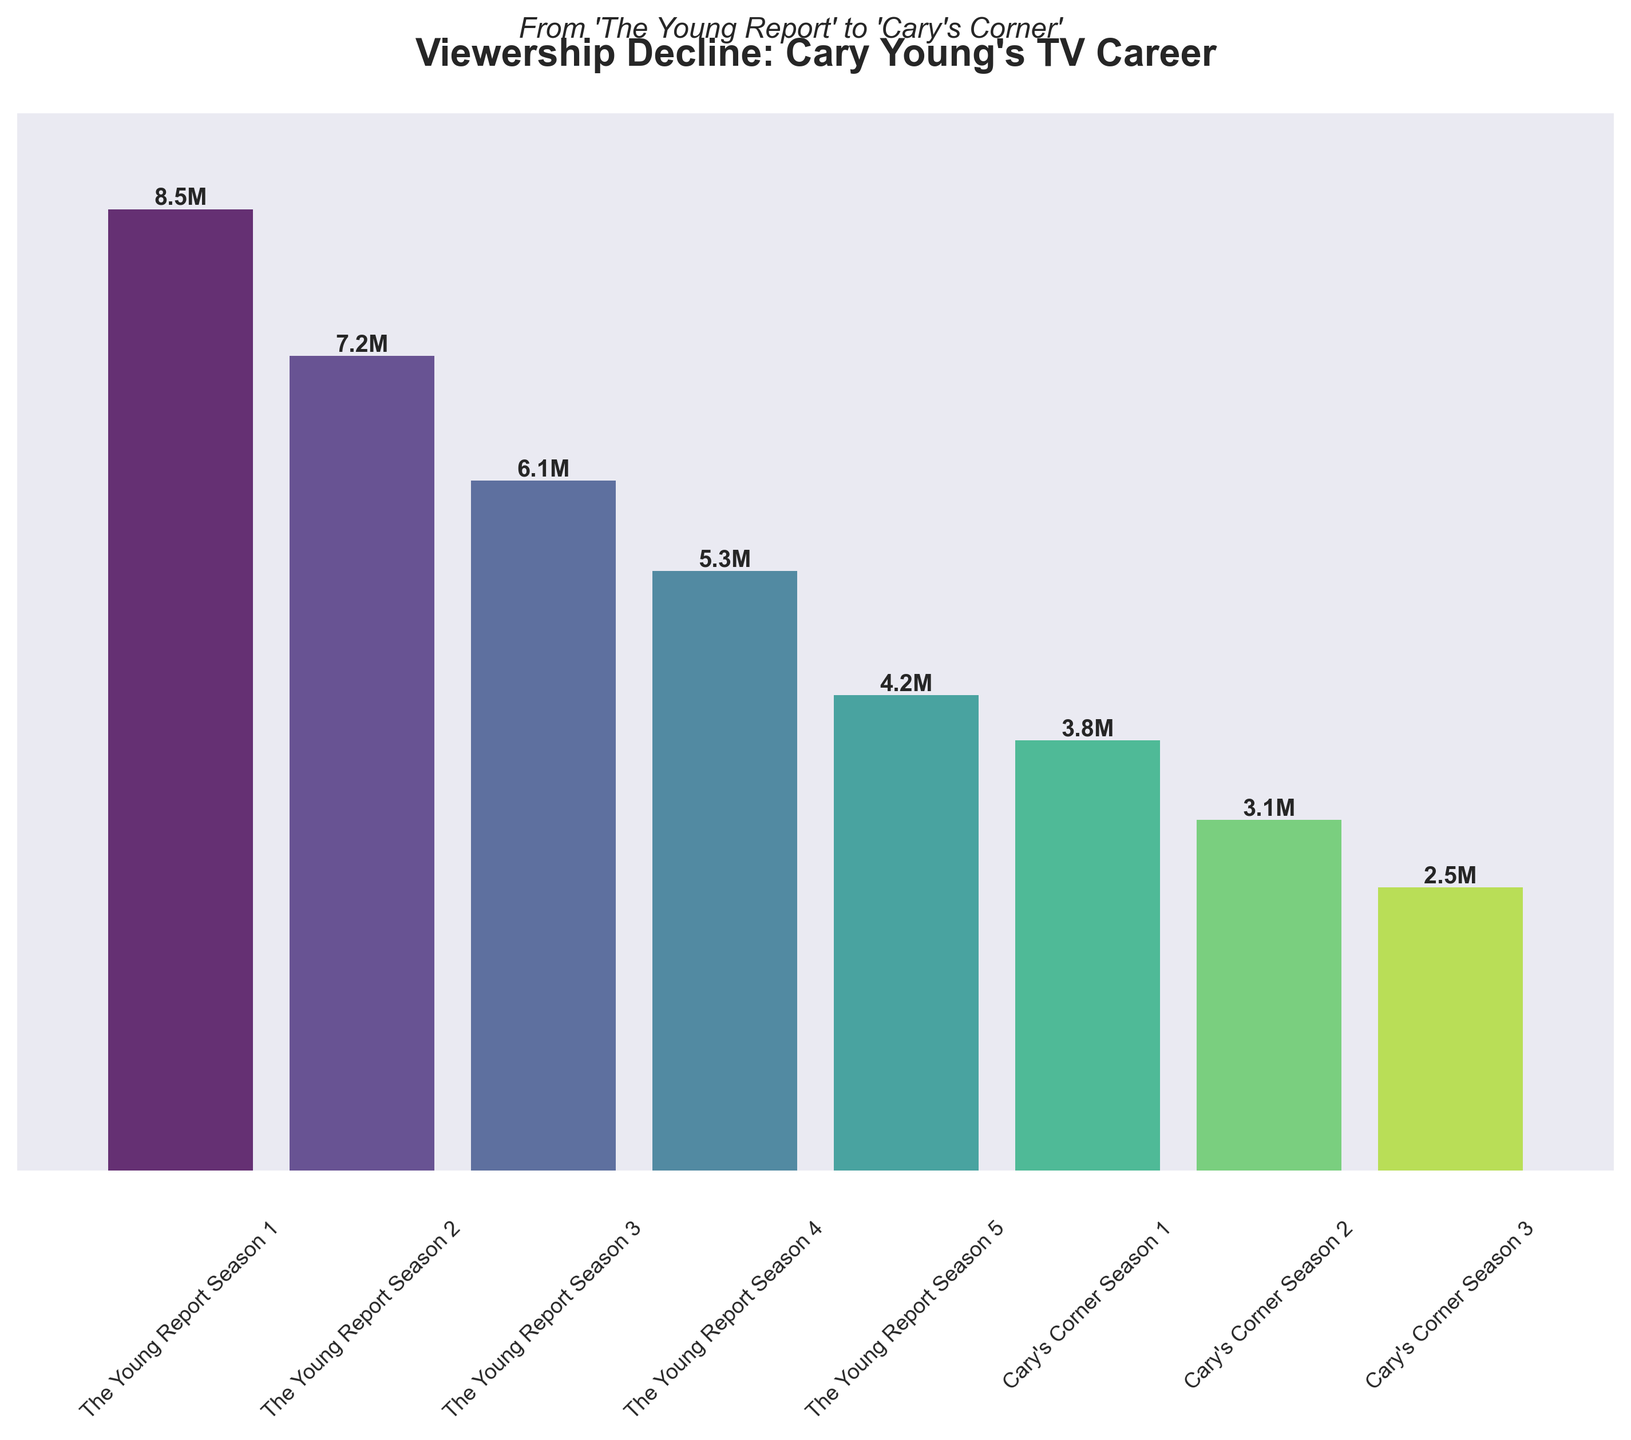What is the title of the figure? The title is located at the top of the figure and reads "Viewership Decline: Cary Young's TV Career".
Answer: Viewership Decline: Cary Young's TV Career How many seasons of "The Young Report" are shown in the figure? By counting the labeled sections specific to "The Young Report", we see there are five seasons listed.
Answer: 5 Which season had the highest number of viewers? The tallest bar in the chart indicates the highest viewers. "The Young Report Season 1" is the tallest, representing 8.5 million viewers.
Answer: The Young Report Season 1 What is the viewers difference between "Cary's Corner Season 1" and "Cary's Corner Season 3"? "Cary's Corner Season 1" had 3.8 million viewers and "Cary's Corner Season 3" had 2.5 million viewers. Subtracting these numbers, the difference is 1.3 million viewers.
Answer: 1.3 million What is the average viewership of "The Young Report" seasons? Add up the viewers from all five seasons (8.5 + 7.2 + 6.1 + 5.3 + 4.2) and divide by the number of seasons, which is 5. Total = 31.3 million; average = 31.3 / 5.
Answer: 6.26 million Which show experienced a steeper decline in viewership from its first to its last season? Compare the first and last season of each show. "The Young Report" dropped from 8.5 million to 4.2 million (a decline of 4.3 million), while "Cary's Corner" dropped from 3.8 million to 2.5 million (a decline of 1.3 million). "The Young Report" has a steeper decline.
Answer: The Young Report What is the viewership for "The Young Report Season 3"? Refer to the height of the bar labeled "The Young Report Season 3", which shows 6.1 million viewers.
Answer: 6.1 million How much did viewership decrease from "The Young Report Season 2" to "The Young Report Season 3"? Subtract the viewers of "The Young Report Season 3" from those of "The Young Report Season 2" (7.2 - 6.1). The decrease is 1.1 million viewers.
Answer: 1.1 million How many seasons of Cary Young's shows are displayed in total? Count all the seasons for both "The Young Report" and "Cary's Corner" across the entire chart. There are 5 from "The Young Report" and 3 from "Cary's Corner", totaling 8 seasons.
Answer: 8 What's the percentage drop in viewership from "The Young Report Season 1" to "The Young Report Season 5"? Calculate the percentage drop by subtracting the viewership of Season 5 from Season 1 and then divide by the number of Season 1 viewers: (8.5 - 4.2) / 8.5 * 100%. The drop is around 50.6%.
Answer: 50.6% 